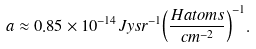<formula> <loc_0><loc_0><loc_500><loc_500>a \approx 0 . 8 5 \times 1 0 ^ { - 1 4 } J y s r ^ { - 1 } { \left ( \frac { H a t o m s } { c m ^ { - 2 } } \right ) } ^ { - 1 } .</formula> 